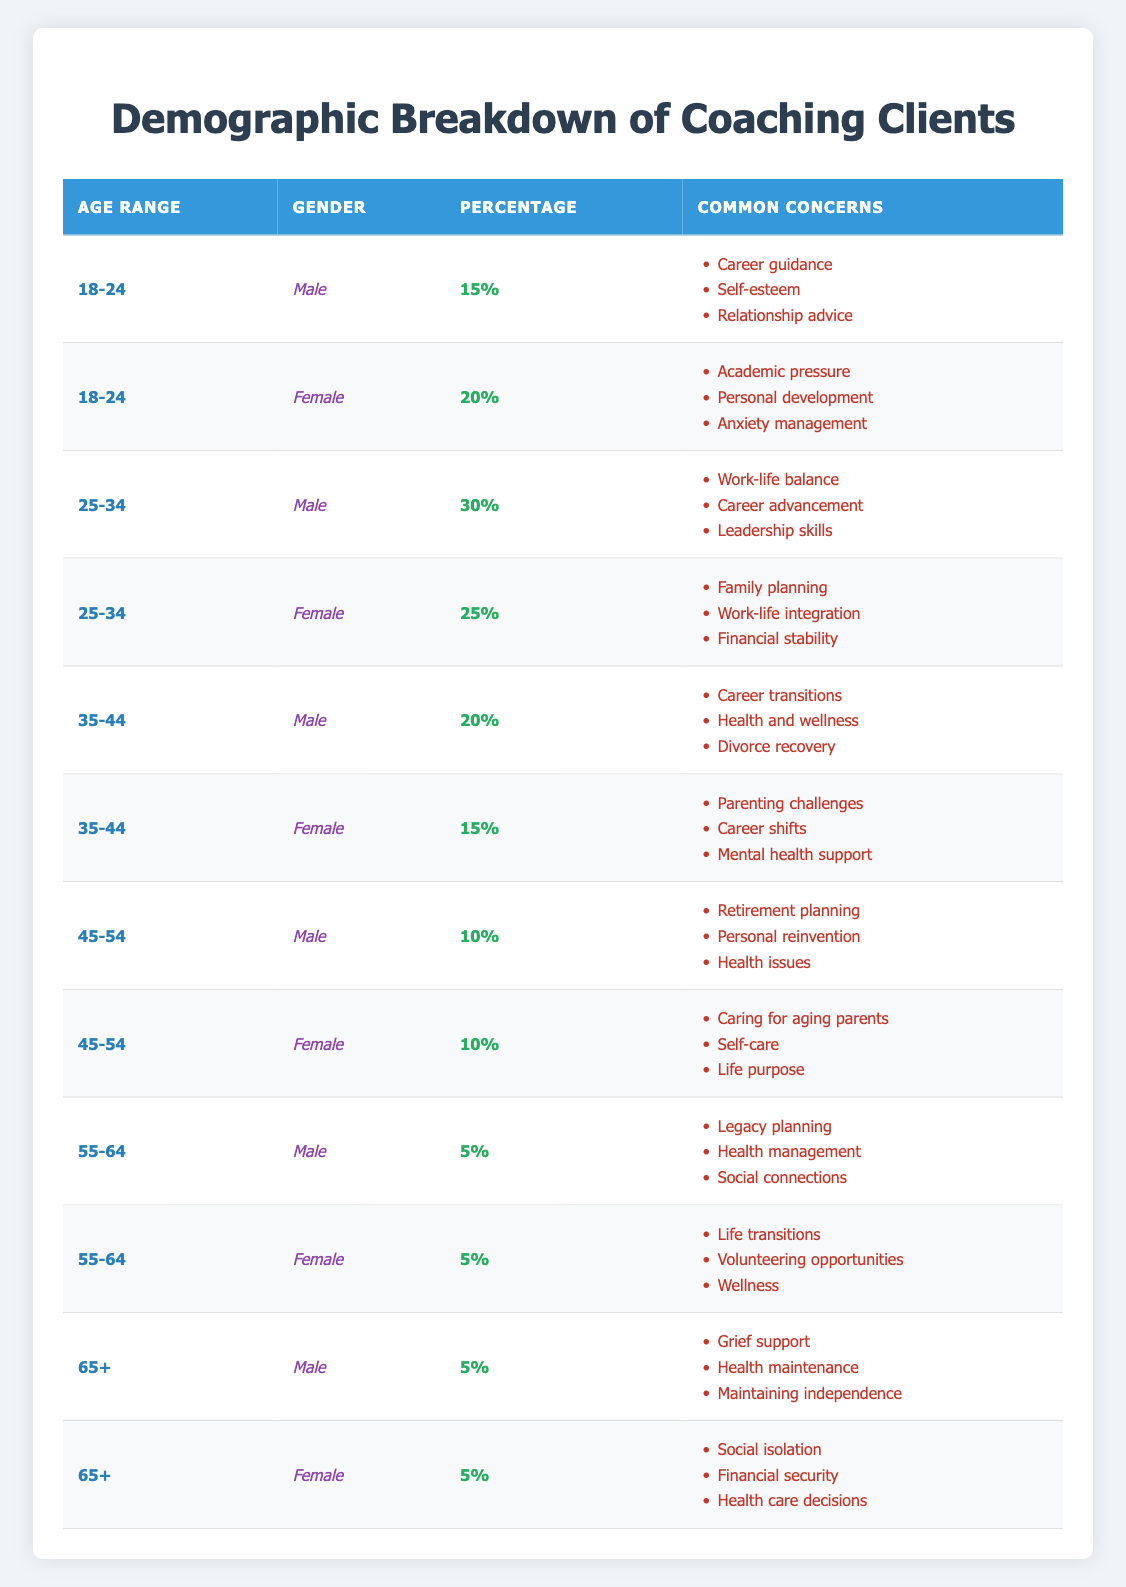What percentage of coaching clients are female between the ages of 25-34? In the table, we find two rows for the age range of 25-34. The percentage for females in this age range is listed as 25%.
Answer: 25% Which age range has the highest representation of male coaching clients? The table indicates that for males, the age range of 25-34 has the highest percentage at 30%.
Answer: 25-34 Is it true that females aged 45-54 have the same percentage representation as males aged 45-54? The table shows that both males and females in the age range of 45-54 have a percentage representation of 10%, making this statement true.
Answer: Yes What is the combined percentage of male coaching clients across all age ranges? To find this, we sum the percentages from each male segment: 15 + 30 + 20 + 10 + 5 + 5 = 85%. The total combined percentage for males is 85%.
Answer: 85% What are the common concerns for females aged 35-44? The table shows that the common concerns for females in the 35-44 age range include parenting challenges, career shifts, and mental health support.
Answer: Parenting challenges, career shifts, mental health support What is the total percentage of coaching clients aged 55-64? The table shows that both males and females aged 55-64 each account for 5%. Thus, the total percentage is 5 + 5 = 10%.
Answer: 10% Which gender has a higher percentage representation in the age range of 18-24? The age range of 18-24 shows that females have a representation of 20%, while males have 15%. Therefore, females have a higher percentage in this age range.
Answer: Female How does the percentage of male coaching clients aged 65+ compare to female coaching clients in the same age range? Both males and females aged 65+ have a percentage of 5%, indicating equality in their representation.
Answer: They are equal at 5% 